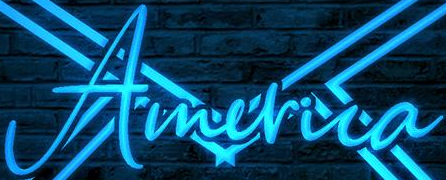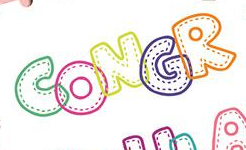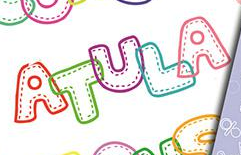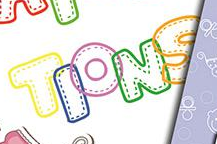Transcribe the words shown in these images in order, separated by a semicolon. America; CONGR; ATULA; TIONS 